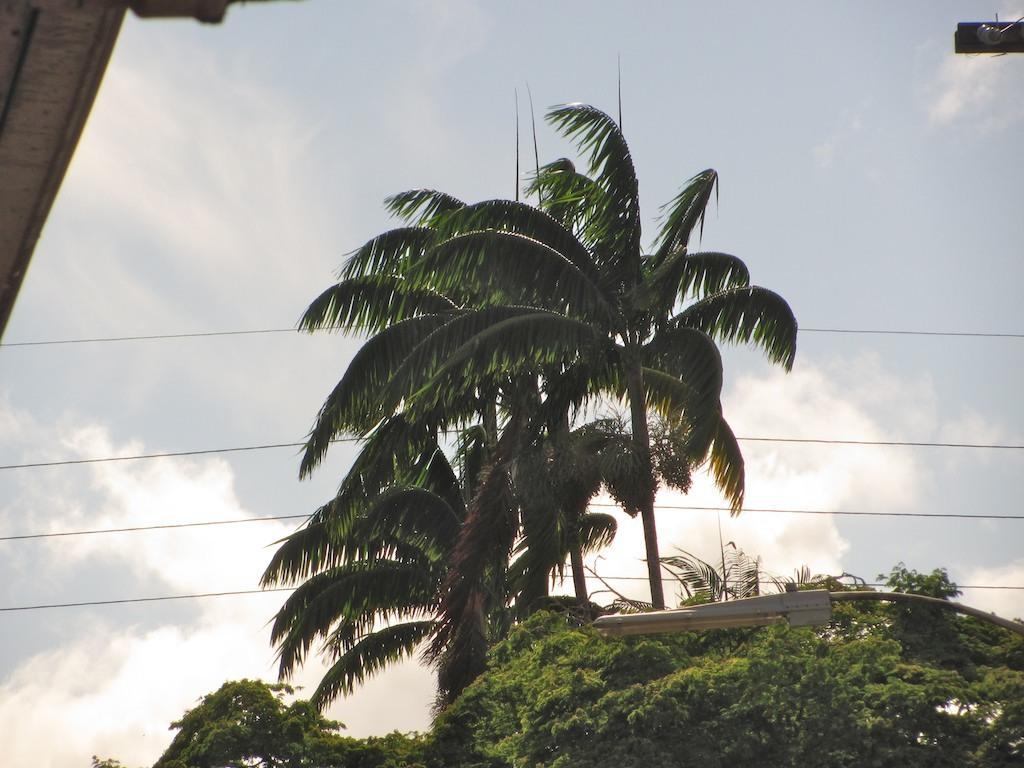In one or two sentences, can you explain what this image depicts? In the image there are many trees and in between the trees there are some wires, there is a street light on the right side. 